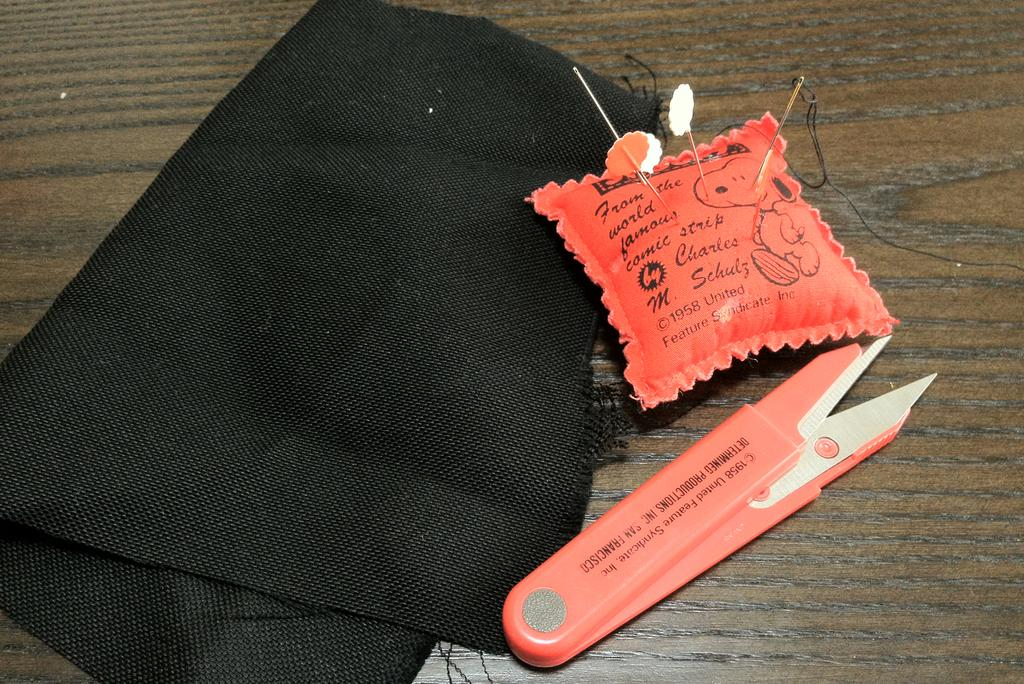<image>
Write a terse but informative summary of the picture. a sewing kit from determined productions with Snoopy 